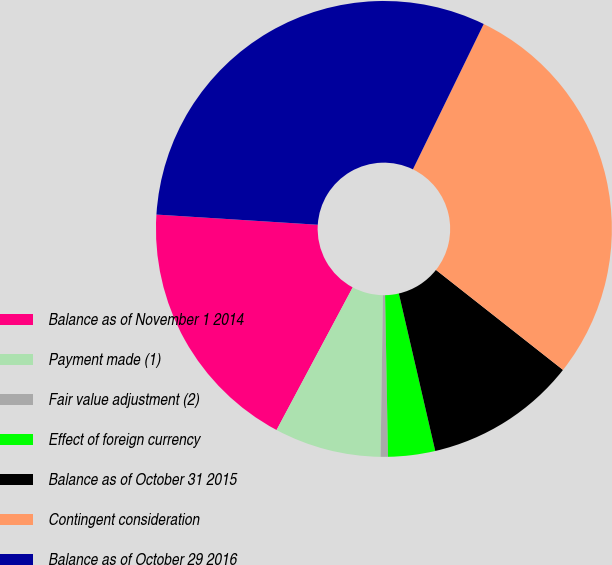Convert chart to OTSL. <chart><loc_0><loc_0><loc_500><loc_500><pie_chart><fcel>Balance as of November 1 2014<fcel>Payment made (1)<fcel>Fair value adjustment (2)<fcel>Effect of foreign currency<fcel>Balance as of October 31 2015<fcel>Contingent consideration<fcel>Balance as of October 29 2016<nl><fcel>18.2%<fcel>7.57%<fcel>0.52%<fcel>3.33%<fcel>10.77%<fcel>28.4%<fcel>31.21%<nl></chart> 